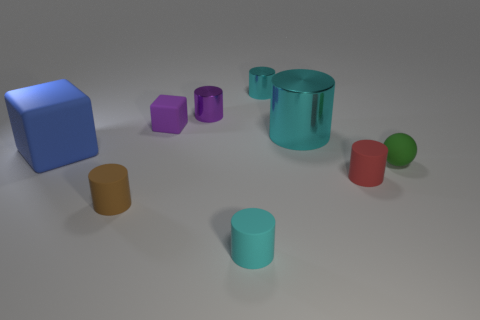There is a thing to the left of the brown matte cylinder that is in front of the big blue thing; what is its color?
Your answer should be very brief. Blue. What number of small things are either red things or cyan rubber things?
Offer a very short reply. 2. There is a matte object that is behind the tiny red thing and in front of the big blue matte object; what is its color?
Offer a terse response. Green. Does the tiny ball have the same material as the large cylinder?
Provide a short and direct response. No. What is the shape of the small green thing?
Make the answer very short. Sphere. There is a cyan cylinder that is in front of the tiny red matte thing that is in front of the tiny purple cube; what number of tiny brown things are to the left of it?
Offer a very short reply. 1. There is a large metal object that is the same shape as the small red thing; what color is it?
Make the answer very short. Cyan. The small cyan thing that is behind the tiny green thing that is right of the small cyan shiny object behind the large cyan thing is what shape?
Your answer should be compact. Cylinder. What is the size of the cyan cylinder that is both behind the tiny brown cylinder and in front of the tiny purple cube?
Your answer should be compact. Large. Is the number of small matte blocks less than the number of blue metal balls?
Your answer should be very brief. No. 